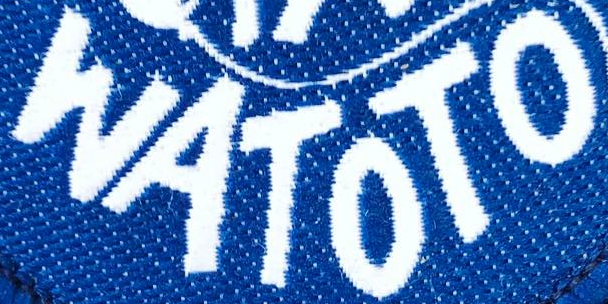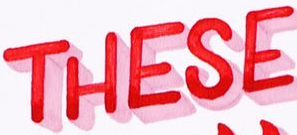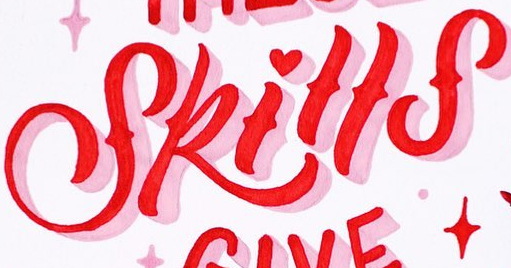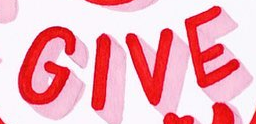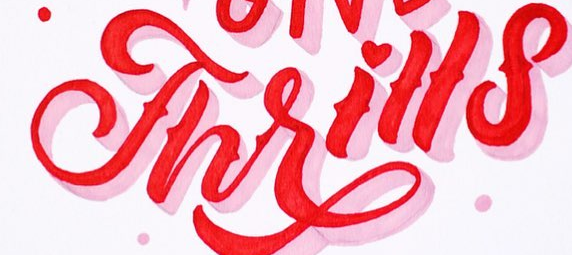Identify the words shown in these images in order, separated by a semicolon. WATOTO; THESE; Skills; GIVE; Thrills 